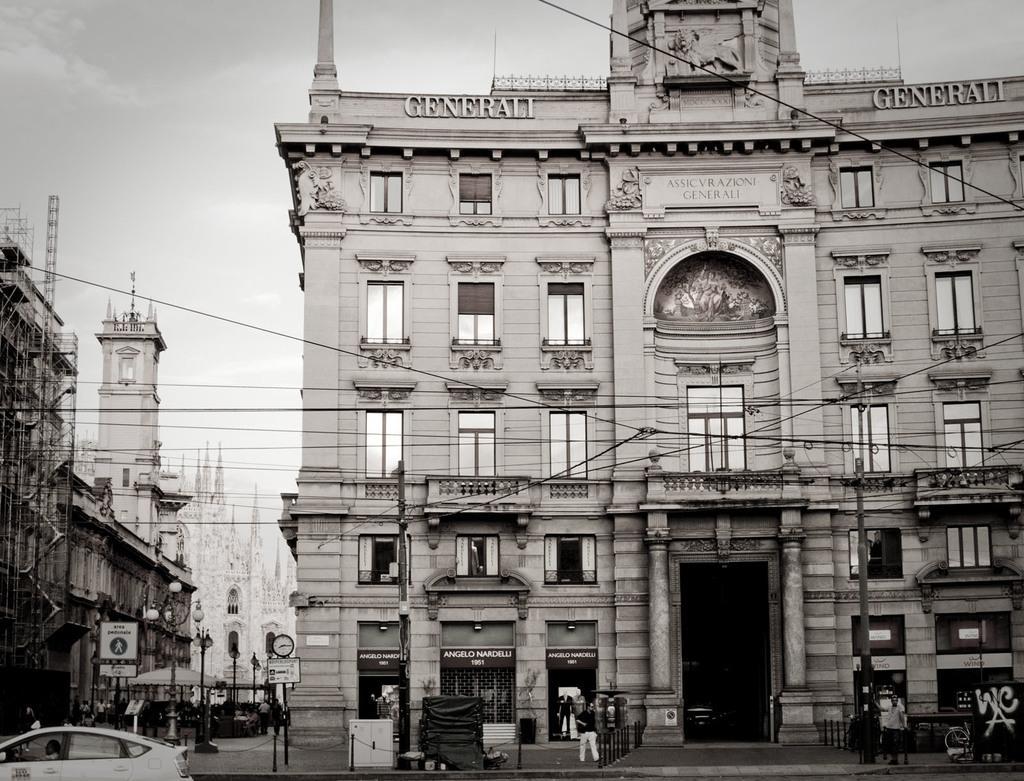Can you describe this image briefly? In this picture we can see a vehicle, beside this vehicle we can see a fence, buildings, people on the ground, here we can see name boards, clock, sign board, umbrella, electric poles with lights, wires and some objects and we can see a wall in the background. 